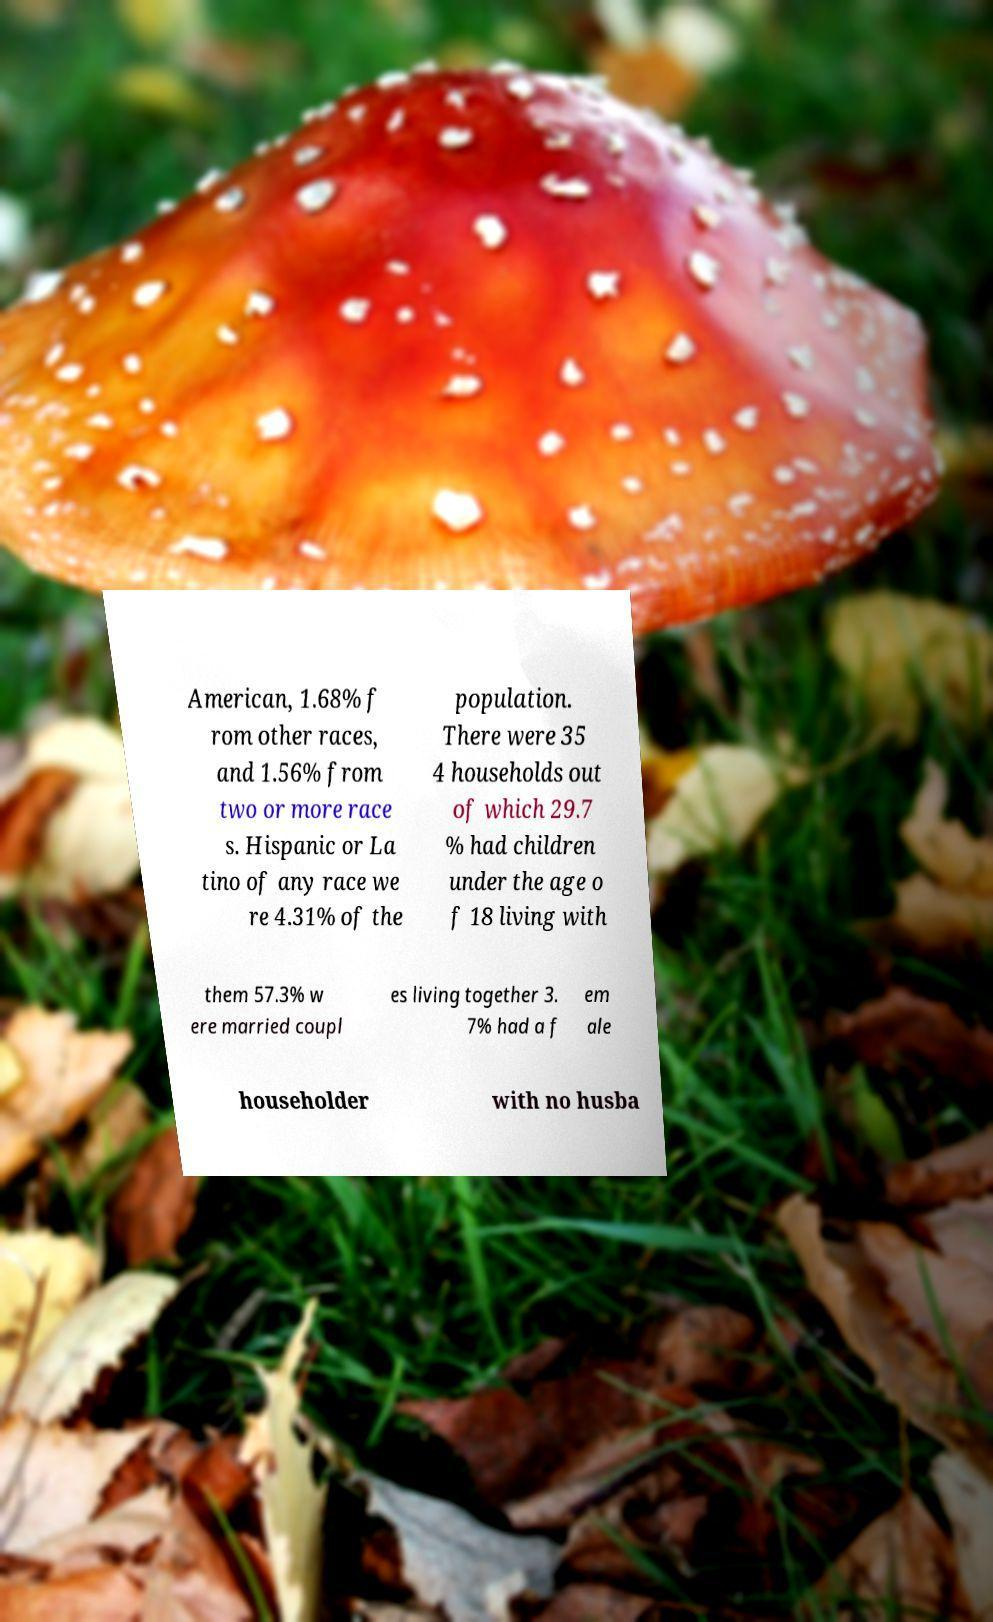For documentation purposes, I need the text within this image transcribed. Could you provide that? American, 1.68% f rom other races, and 1.56% from two or more race s. Hispanic or La tino of any race we re 4.31% of the population. There were 35 4 households out of which 29.7 % had children under the age o f 18 living with them 57.3% w ere married coupl es living together 3. 7% had a f em ale householder with no husba 